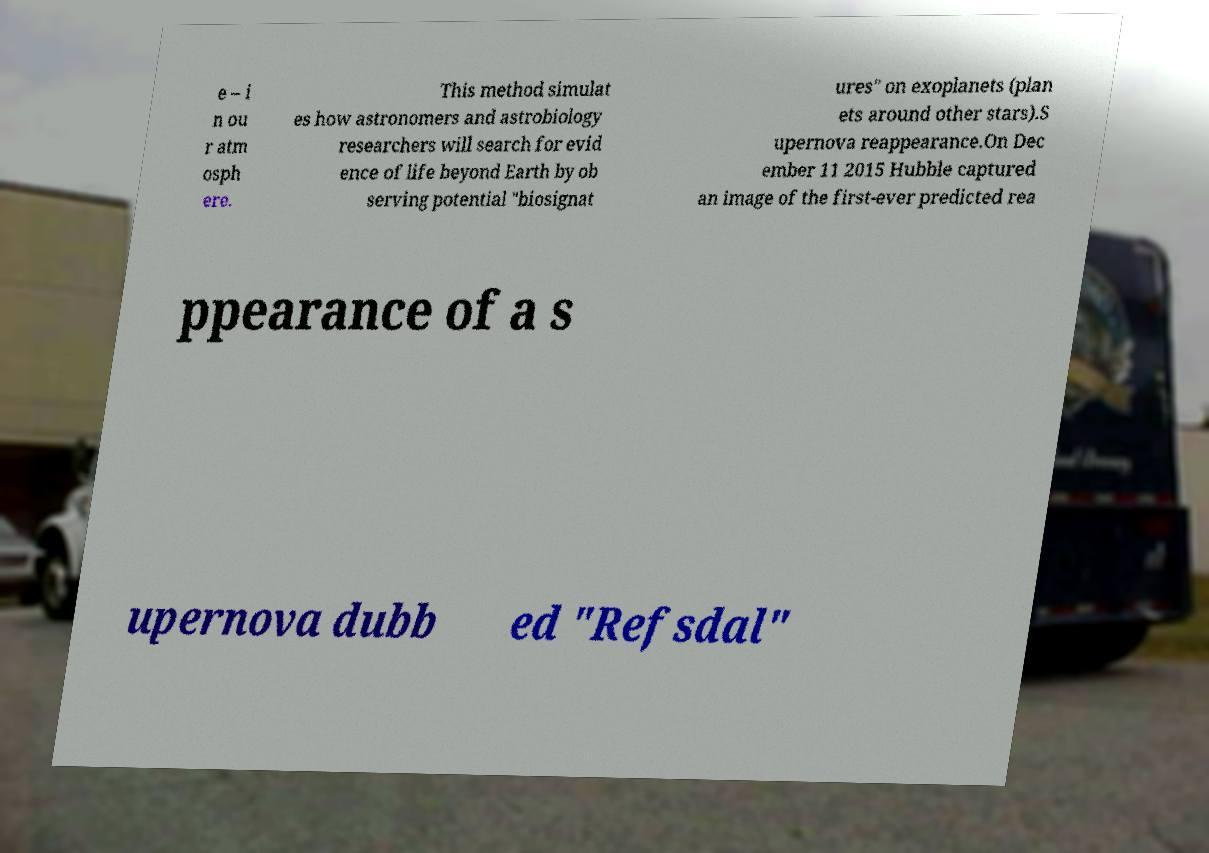Could you extract and type out the text from this image? e – i n ou r atm osph ere. This method simulat es how astronomers and astrobiology researchers will search for evid ence of life beyond Earth by ob serving potential "biosignat ures" on exoplanets (plan ets around other stars).S upernova reappearance.On Dec ember 11 2015 Hubble captured an image of the first-ever predicted rea ppearance of a s upernova dubb ed "Refsdal" 